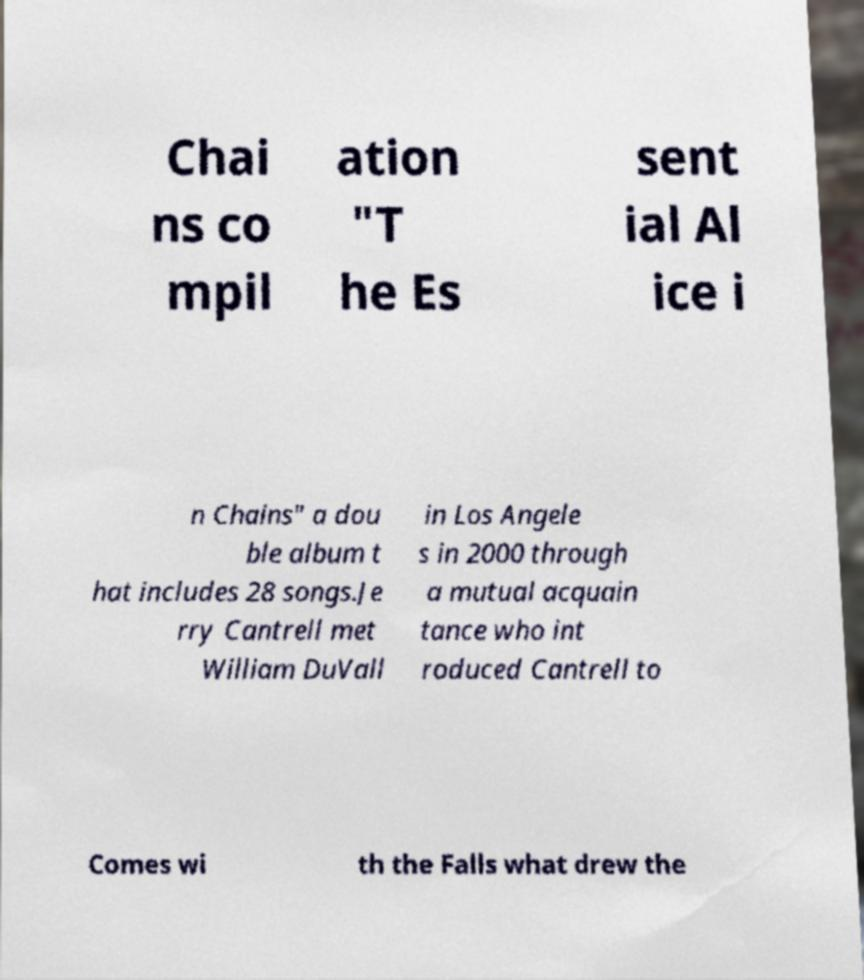Can you read and provide the text displayed in the image?This photo seems to have some interesting text. Can you extract and type it out for me? Chai ns co mpil ation "T he Es sent ial Al ice i n Chains" a dou ble album t hat includes 28 songs.Je rry Cantrell met William DuVall in Los Angele s in 2000 through a mutual acquain tance who int roduced Cantrell to Comes wi th the Falls what drew the 